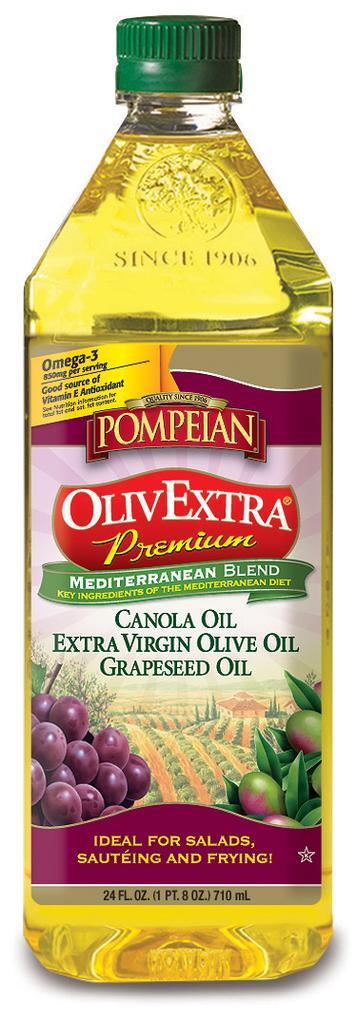Could you give a brief overview of what you see in this image? In this image there is a oil bottle with a label and a cap. 